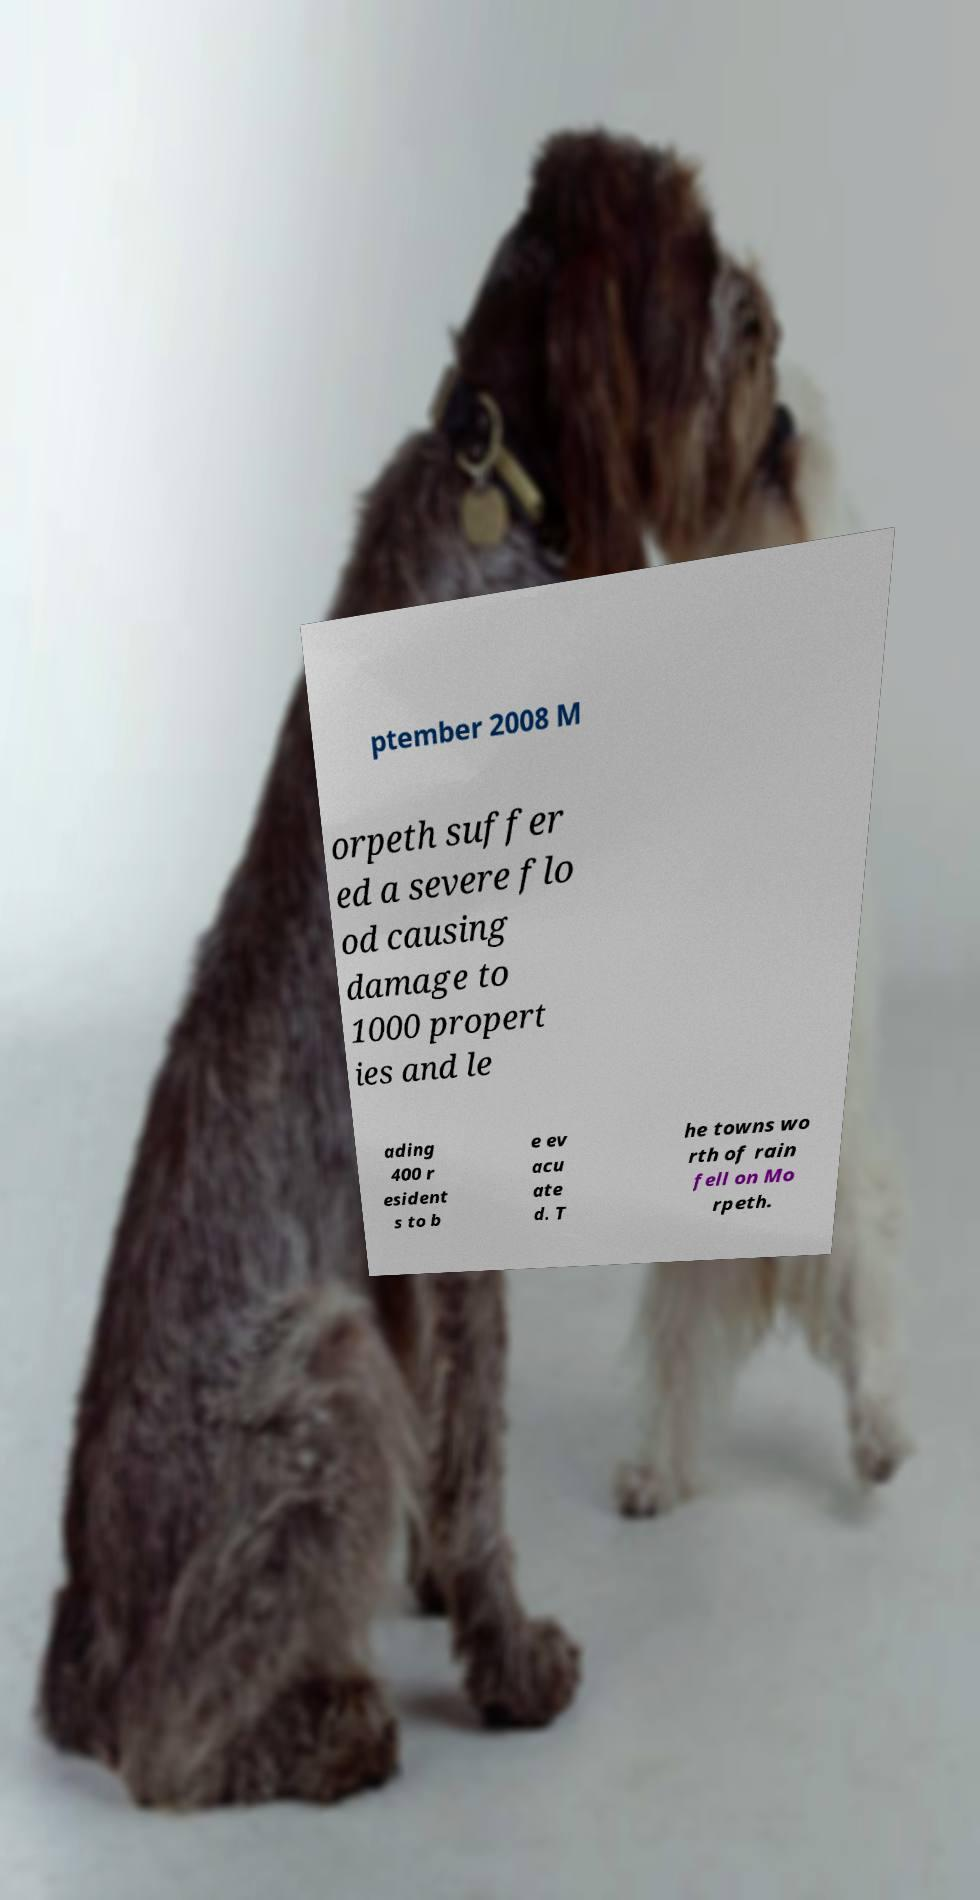I need the written content from this picture converted into text. Can you do that? ptember 2008 M orpeth suffer ed a severe flo od causing damage to 1000 propert ies and le ading 400 r esident s to b e ev acu ate d. T he towns wo rth of rain fell on Mo rpeth. 